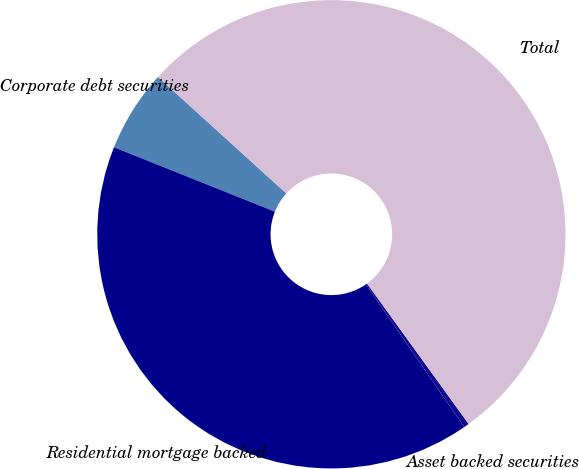Convert chart to OTSL. <chart><loc_0><loc_0><loc_500><loc_500><pie_chart><fcel>Corporate debt securities<fcel>Residential mortgage backed<fcel>Asset backed securities<fcel>Total<nl><fcel>5.67%<fcel>40.66%<fcel>0.37%<fcel>53.3%<nl></chart> 